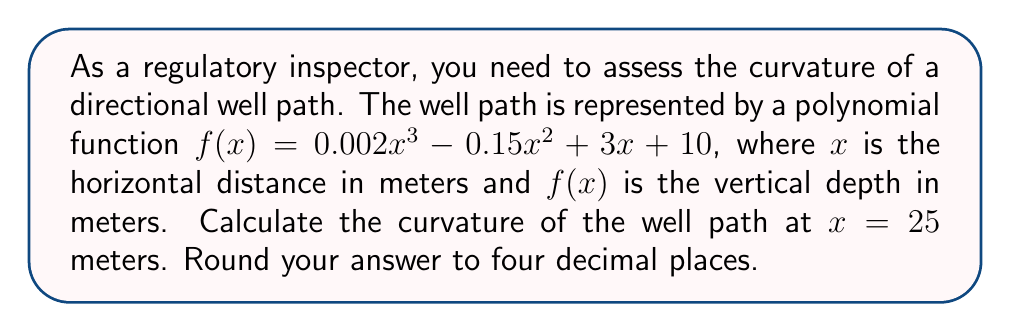Solve this math problem. To calculate the curvature of the well path, we'll use the curvature formula for a function $y = f(x)$:

$$\kappa = \frac{|f''(x)|}{(1 + [f'(x)]^2)^{3/2}}$$

where $f'(x)$ is the first derivative and $f''(x)$ is the second derivative of the function.

Step 1: Calculate $f'(x)$
$$f'(x) = 0.006x^2 - 0.3x + 3$$

Step 2: Calculate $f''(x)$
$$f''(x) = 0.012x - 0.3$$

Step 3: Evaluate $f'(x)$ and $f''(x)$ at $x = 25$
$$f'(25) = 0.006(25)^2 - 0.3(25) + 3 = 3.75 - 7.5 + 3 = -0.75$$
$$f''(25) = 0.012(25) - 0.3 = 0.3 - 0.3 = 0$$

Step 4: Apply the curvature formula
$$\kappa = \frac{|f''(25)|}{(1 + [f'(25)]^2)^{3/2}}$$
$$\kappa = \frac{|0|}{(1 + [-0.75]^2)^{3/2}}$$
$$\kappa = \frac{0}{(1 + 0.5625)^{3/2}}$$
$$\kappa = \frac{0}{1.5625^{3/2}}$$
$$\kappa = 0$$

Therefore, the curvature at $x = 25$ meters is 0.
Answer: 0.0000 